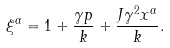Convert formula to latex. <formula><loc_0><loc_0><loc_500><loc_500>\xi ^ { \alpha } = 1 + \frac { \gamma p } { k } + \frac { J \gamma ^ { 2 } x ^ { \alpha } } { k } .</formula> 